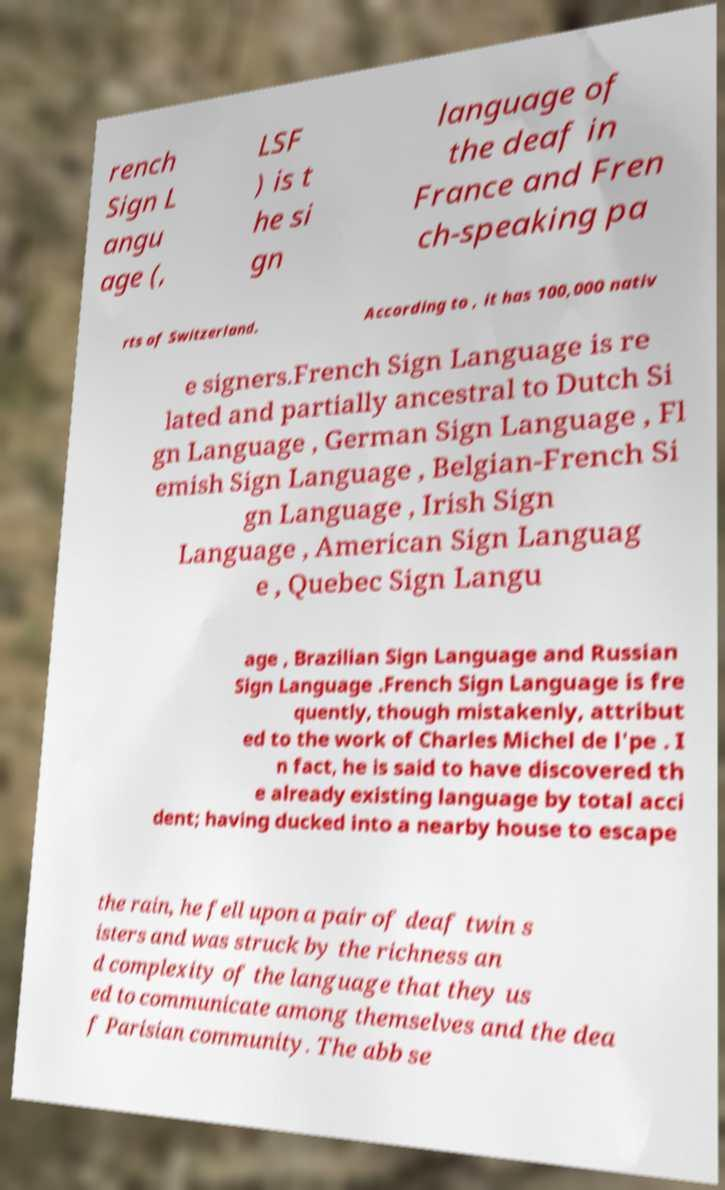There's text embedded in this image that I need extracted. Can you transcribe it verbatim? rench Sign L angu age (, LSF ) is t he si gn language of the deaf in France and Fren ch-speaking pa rts of Switzerland. According to , it has 100,000 nativ e signers.French Sign Language is re lated and partially ancestral to Dutch Si gn Language , German Sign Language , Fl emish Sign Language , Belgian-French Si gn Language , Irish Sign Language , American Sign Languag e , Quebec Sign Langu age , Brazilian Sign Language and Russian Sign Language .French Sign Language is fre quently, though mistakenly, attribut ed to the work of Charles Michel de l'pe . I n fact, he is said to have discovered th e already existing language by total acci dent; having ducked into a nearby house to escape the rain, he fell upon a pair of deaf twin s isters and was struck by the richness an d complexity of the language that they us ed to communicate among themselves and the dea f Parisian community. The abb se 